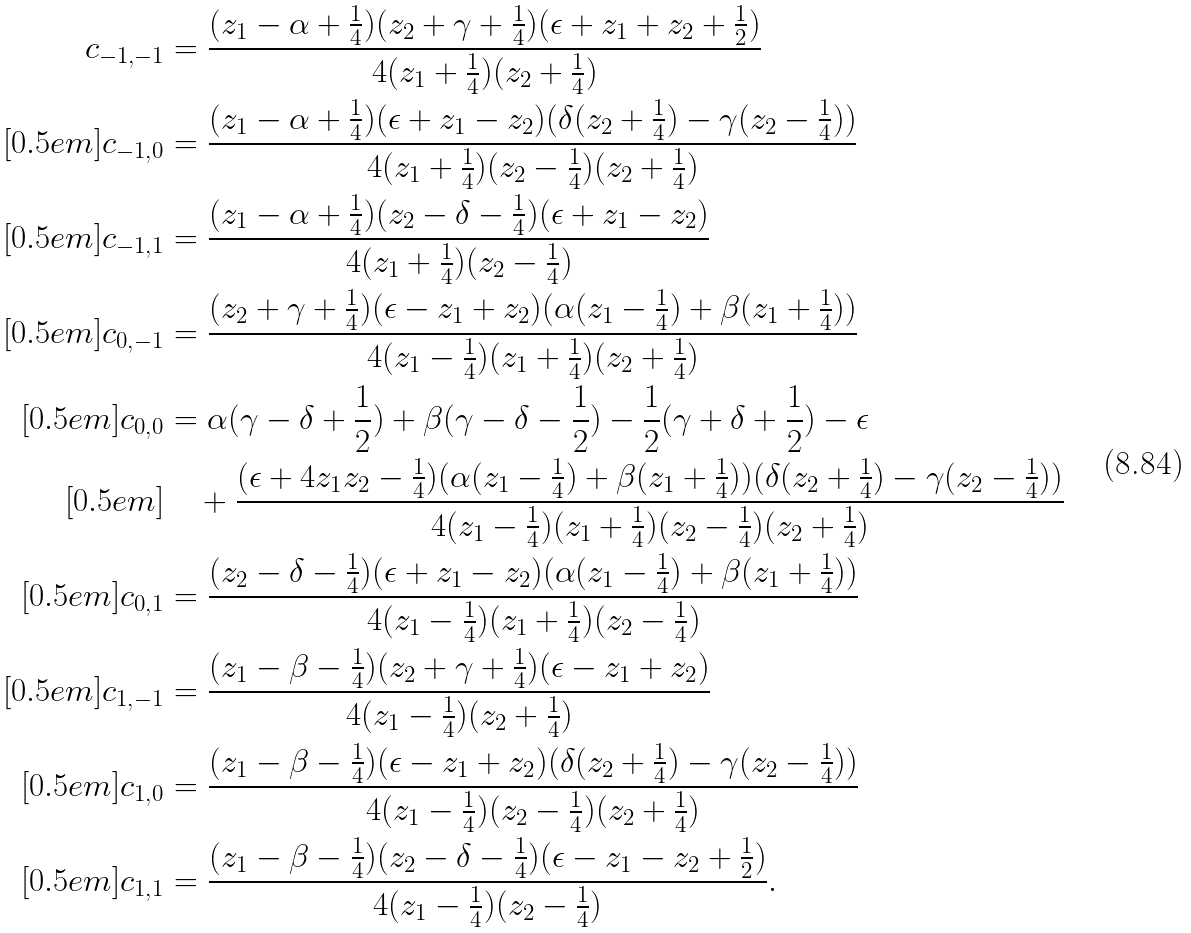<formula> <loc_0><loc_0><loc_500><loc_500>c _ { - 1 , - 1 } & = \frac { ( z _ { 1 } - \alpha + \frac { 1 } { 4 } ) ( z _ { 2 } + \gamma + \frac { 1 } { 4 } ) ( \epsilon + z _ { 1 } + z _ { 2 } + \frac { 1 } { 2 } ) } { 4 ( z _ { 1 } + \frac { 1 } { 4 } ) ( z _ { 2 } + \frac { 1 } { 4 } ) } \\ [ 0 . 5 e m ] c _ { - 1 , 0 } & = \frac { ( z _ { 1 } - \alpha + \frac { 1 } { 4 } ) ( \epsilon + z _ { 1 } - z _ { 2 } ) ( \delta ( z _ { 2 } + \frac { 1 } { 4 } ) - \gamma ( z _ { 2 } - \frac { 1 } { 4 } ) ) } { 4 ( z _ { 1 } + \frac { 1 } { 4 } ) ( z _ { 2 } - \frac { 1 } { 4 } ) ( z _ { 2 } + \frac { 1 } { 4 } ) } \\ [ 0 . 5 e m ] c _ { - 1 , 1 } & = \frac { ( z _ { 1 } - \alpha + \frac { 1 } { 4 } ) ( z _ { 2 } - \delta - \frac { 1 } { 4 } ) ( \epsilon + z _ { 1 } - z _ { 2 } ) } { 4 ( z _ { 1 } + \frac { 1 } { 4 } ) ( z _ { 2 } - \frac { 1 } { 4 } ) } \\ [ 0 . 5 e m ] c _ { 0 , - 1 } & = \frac { ( z _ { 2 } + \gamma + \frac { 1 } { 4 } ) ( \epsilon - z _ { 1 } + z _ { 2 } ) ( \alpha ( z _ { 1 } - \frac { 1 } { 4 } ) + \beta ( z _ { 1 } + \frac { 1 } { 4 } ) ) } { 4 ( z _ { 1 } - \frac { 1 } { 4 } ) ( z _ { 1 } + \frac { 1 } { 4 } ) ( z _ { 2 } + \frac { 1 } { 4 } ) } \\ [ 0 . 5 e m ] c _ { 0 , 0 } & = \alpha ( \gamma - \delta + \frac { 1 } { 2 } ) + \beta ( \gamma - \delta - \frac { 1 } { 2 } ) - \frac { 1 } { 2 } ( \gamma + \delta + \frac { 1 } { 2 } ) - \epsilon \\ [ 0 . 5 e m ] & \quad + \frac { ( \epsilon + 4 z _ { 1 } z _ { 2 } - \frac { 1 } { 4 } ) ( \alpha ( z _ { 1 } - \frac { 1 } { 4 } ) + \beta ( z _ { 1 } + \frac { 1 } { 4 } ) ) ( \delta ( z _ { 2 } + \frac { 1 } { 4 } ) - \gamma ( z _ { 2 } - \frac { 1 } { 4 } ) ) } { 4 ( z _ { 1 } - \frac { 1 } { 4 } ) ( z _ { 1 } + \frac { 1 } { 4 } ) ( z _ { 2 } - \frac { 1 } { 4 } ) ( z _ { 2 } + \frac { 1 } { 4 } ) } \\ [ 0 . 5 e m ] c _ { 0 , 1 } & = \frac { ( z _ { 2 } - \delta - \frac { 1 } { 4 } ) ( \epsilon + z _ { 1 } - z _ { 2 } ) ( \alpha ( z _ { 1 } - \frac { 1 } { 4 } ) + \beta ( z _ { 1 } + \frac { 1 } { 4 } ) ) } { 4 ( z _ { 1 } - \frac { 1 } { 4 } ) ( z _ { 1 } + \frac { 1 } { 4 } ) ( z _ { 2 } - \frac { 1 } { 4 } ) } \\ [ 0 . 5 e m ] c _ { 1 , - 1 } & = \frac { ( z _ { 1 } - \beta - \frac { 1 } { 4 } ) ( z _ { 2 } + \gamma + \frac { 1 } { 4 } ) ( \epsilon - z _ { 1 } + z _ { 2 } ) } { 4 ( z _ { 1 } - \frac { 1 } { 4 } ) ( z _ { 2 } + \frac { 1 } { 4 } ) } \\ [ 0 . 5 e m ] c _ { 1 , 0 } & = \frac { ( z _ { 1 } - \beta - \frac { 1 } { 4 } ) ( \epsilon - z _ { 1 } + z _ { 2 } ) ( \delta ( z _ { 2 } + \frac { 1 } { 4 } ) - \gamma ( z _ { 2 } - \frac { 1 } { 4 } ) ) } { 4 ( z _ { 1 } - \frac { 1 } { 4 } ) ( z _ { 2 } - \frac { 1 } { 4 } ) ( z _ { 2 } + \frac { 1 } { 4 } ) } \\ [ 0 . 5 e m ] c _ { 1 , 1 } & = \frac { ( z _ { 1 } - \beta - \frac { 1 } { 4 } ) ( z _ { 2 } - \delta - \frac { 1 } { 4 } ) ( \epsilon - z _ { 1 } - z _ { 2 } + \frac { 1 } { 2 } ) } { 4 ( z _ { 1 } - \frac { 1 } { 4 } ) ( z _ { 2 } - \frac { 1 } { 4 } ) } .</formula> 